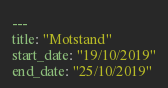<code> <loc_0><loc_0><loc_500><loc_500><_YAML_>---
title: "Motstand"
start_date: "19/10/2019"
end_date: "25/10/2019"</code> 